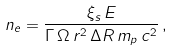<formula> <loc_0><loc_0><loc_500><loc_500>n _ { e } = \frac { \xi _ { s } \, E } { \Gamma \, \Omega \, r ^ { 2 } \, \Delta R \, m _ { p } \, c ^ { 2 } } \, ,</formula> 